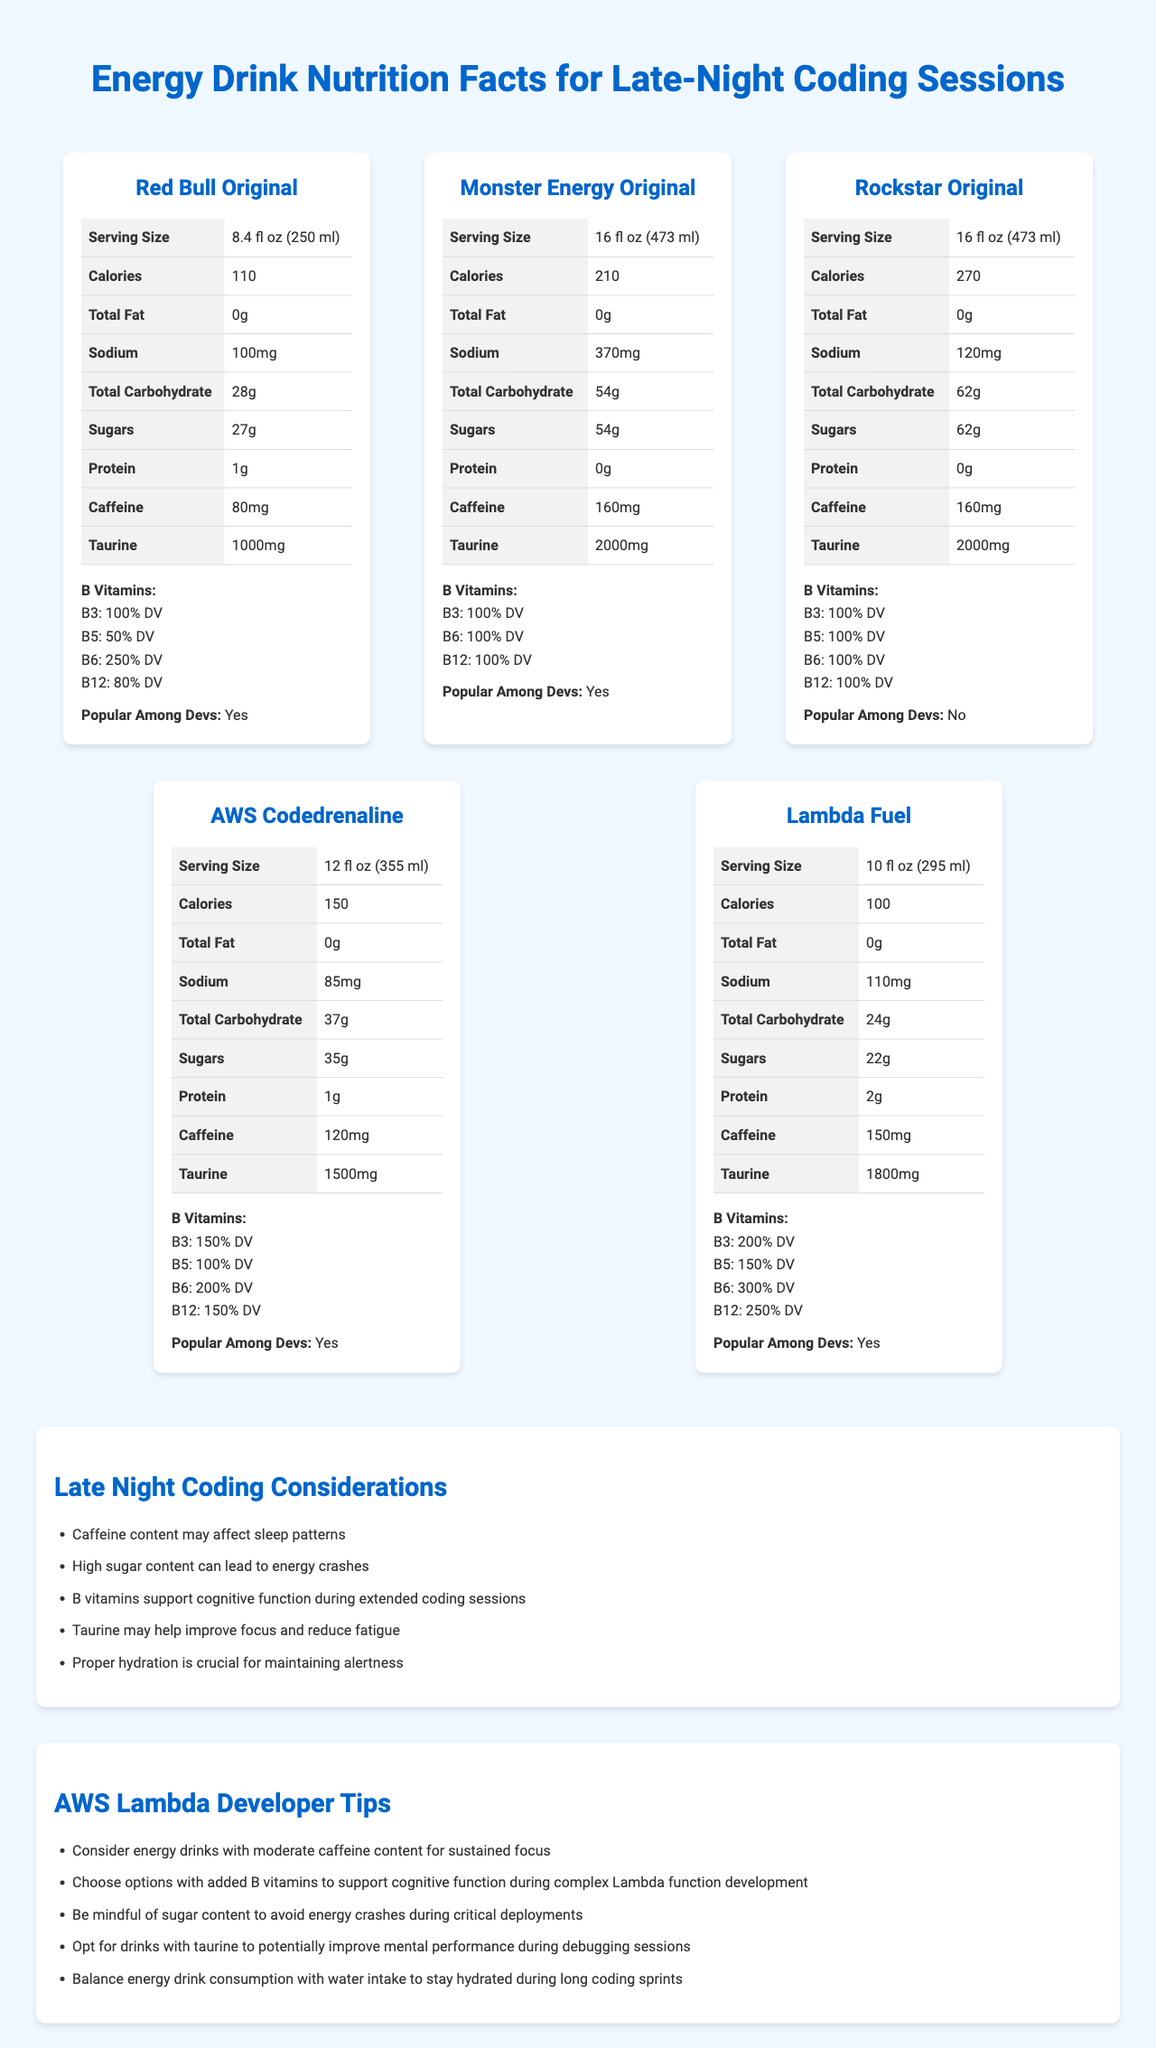what is the serving size of Red Bull Original? The serving size is listed next to the "Serving Size" attribute under Red Bull Original.
Answer: 8.4 fl oz (250 ml) how many grams of sugars does Monster Energy Original contain per serving? Each serving of Monster Energy Original contains 54 grams of sugars, as indicated under the "Sugars" attribute.
Answer: 54 grams which energy drink has the highest calorie content per serving? Rockstar Original has the highest calorie content with 270 calories per serving, as listed under the "Calories" attribute.
Answer: Rockstar Original how much caffeine does AWS Codedrenaline contain? AWS Codedrenaline contains 120 mg of caffeine, as shown under the "Caffeine" attribute.
Answer: 120 mg does Lambda Fuel contain ginseng? The drink card for Lambda Fuel lists 200 mg of ginseng under the nutrient details.
Answer: Yes which drink is least popular among developers? A. Red Bull Original B. Monster Energy Original C. Rockstar Original D. AWS Codedrenaline E. Lambda Fuel Rockstar Original is marked as "No" under the "Popular Among Devs" attribute, unlike the other drinks.
Answer: Rockstar Original which drink has the highest sodium content per serving? A. Red Bull Original B. Monster Energy Original C. Rockstar Original D. AWS Codedrenaline Monster Energy Original has the highest sodium content with 370 mg per serving, listed under "Sodium".
Answer: B. Monster Energy Original based on the label, should you choose options with added B vitamins? Adding B vitamins supports cognitive function during extended coding sessions, as recommended in the "AWS Lambda Developer Tips" section.
Answer: Yes which energy drink has the highest percentage daily value (DV) of Vitamin B3? Lambda Fuel has 200% DV of Vitamin B3, as visually displayed in the document.
Answer: Lambda Fuel does higher taurine content likely help improve focus and reduce fatigue during late-night coding sessions? Taurine content is said to help improve focus and reduce fatigue according to the "Late Night Coding Considerations" section.
Answer: Yes which energy drink has the smallest serving size? Lambda Fuel has a serving size of 10 fl oz (295 ml), as indicated in the document.
Answer: Lambda Fuel describe the main content of the document. The document includes detailed nutrition information for several energy drinks and considerations for optimal performance during late-night coding. It also provides contextual tips for developers.
Answer: The document provides comparative nutrition facts for popular energy drinks consumed during late-night coding sessions, highlighting attributes such as calorie content, serving size, caffeine, sugars, B-vitamins, taurine, and popularity among developers. Additionally, it includes considerations for late-night coding and tips for AWS Lambda developers. what percentage of the daily value for Vitamin B12 does AWS Codedrenaline provide? AWS Codedrenaline provides 150% DV of Vitamin B12, as indicated in the nutrition facts.
Answer: 150% DV how many grams of protein does Lambda Fuel contain? Lambda Fuel contains 2 grams of protein, as listed under the "Protein" attribute.
Answer: 2 grams which energy drink has the least amount of sugars? Lambda Fuel contains 22 grams of sugars, which is the least among the options.
Answer: Lambda Fuel what are the recommendations for AWS Lambda developers regarding energy drinks? The last section titled "AWS Lambda Developer Tips" provides these recommendations to optimize performance during coding sprints.
Answer: Consider energy drinks with moderate caffeine content, added B vitamins, mind sugar content, look for taurine, balance with water intake what ingredients do these energy drinks contain that help improve focus during coding sessions? The document mentions taurine and B vitamins, indicating they help improve focus and cognitive function.
Answer: Taurine and B vitamins which energy drink has the highest caffeine content? Both Monster Energy Original and Rockstar Original contain 160 mg of caffeine per serving.
Answer: Monster Energy Original and Rockstar Original how much taurine does Red Bull Original contain per serving? Red Bull Original contains 1000 mg of taurine per serving, as listed in its nutrition facts.
Answer: 1000 mg which energy drink has the most servings per container? Both Monster Energy Original and Rockstar Original have 2 servings per container.
Answer: Monster Energy Original and Rockstar Original how does high sugar content affect energy levels during coding? The section "Late Night Coding Considerations" states that high sugar content can lead to energy crashes.
Answer: High sugar content can lead to energy crashes what is the best energy drink for someone who wants added B vitamins and low sugar content? Lambda Fuel provides high percentages of B vitamins and has a relatively low sugar content of 22 grams.
Answer: Lambda Fuel what are the side effects of consuming energy drinks with high caffeine content? The visual information in the document does not address specific side effects of consuming high caffeine content.
Answer: Cannot be determined 